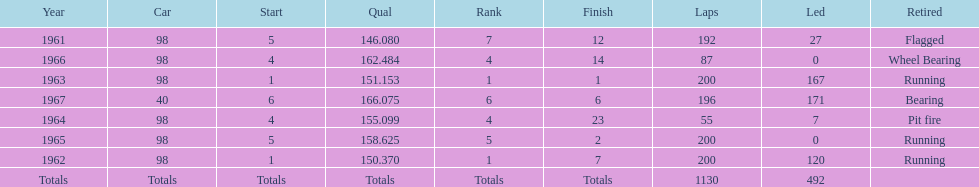What is the most common cause for a retired car? Running. 